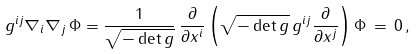<formula> <loc_0><loc_0><loc_500><loc_500>g ^ { i j } \nabla _ { i } \nabla _ { j } \, \Phi = \frac { 1 } { \sqrt { - \det g } } \, \frac { \partial } { \partial x ^ { i } } \left ( { \sqrt { - \det g } } \, g ^ { i j } \frac { \partial } { \partial x ^ { j } } \right ) \Phi \, = \, 0 \, ,</formula> 